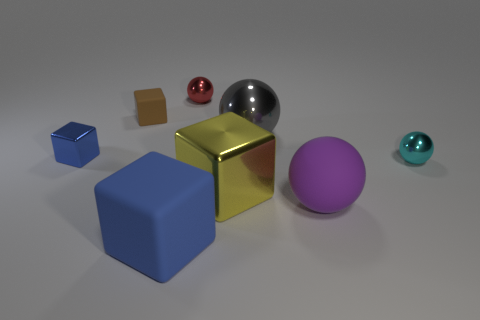Subtract all large purple matte balls. How many balls are left? 3 Add 2 small purple metallic cylinders. How many objects exist? 10 Subtract all blue spheres. How many blue blocks are left? 2 Subtract all blue cubes. How many cubes are left? 2 Subtract 1 cubes. How many cubes are left? 3 Subtract all gray spheres. Subtract all purple cylinders. How many spheres are left? 3 Subtract all big matte things. Subtract all small green shiny cylinders. How many objects are left? 6 Add 1 large matte spheres. How many large matte spheres are left? 2 Add 6 tiny cyan metallic things. How many tiny cyan metallic things exist? 7 Subtract 0 cyan cylinders. How many objects are left? 8 